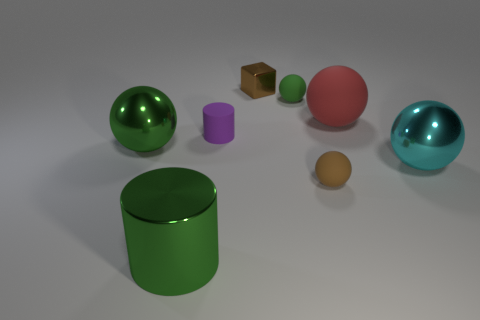Subtract all green balls. How many were subtracted if there are1green balls left? 1 Subtract 2 spheres. How many spheres are left? 3 Subtract all small brown spheres. How many spheres are left? 4 Subtract all red spheres. How many spheres are left? 4 Subtract all blue balls. Subtract all gray cylinders. How many balls are left? 5 Add 1 large red objects. How many objects exist? 9 Add 2 small purple matte cylinders. How many small purple matte cylinders are left? 3 Add 1 brown shiny cubes. How many brown shiny cubes exist? 2 Subtract 0 brown cylinders. How many objects are left? 8 Subtract all cylinders. How many objects are left? 6 